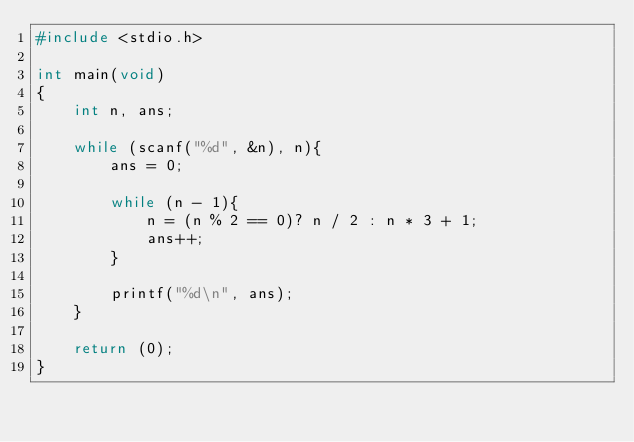<code> <loc_0><loc_0><loc_500><loc_500><_C_>#include <stdio.h>

int main(void)
{
	int n, ans;
	
	while (scanf("%d", &n), n){
		ans = 0;
		
		while (n - 1){
			n = (n % 2 == 0)? n / 2 : n * 3 + 1;
			ans++;
		}
		
		printf("%d\n", ans);
	}
	
	return (0);
}</code> 